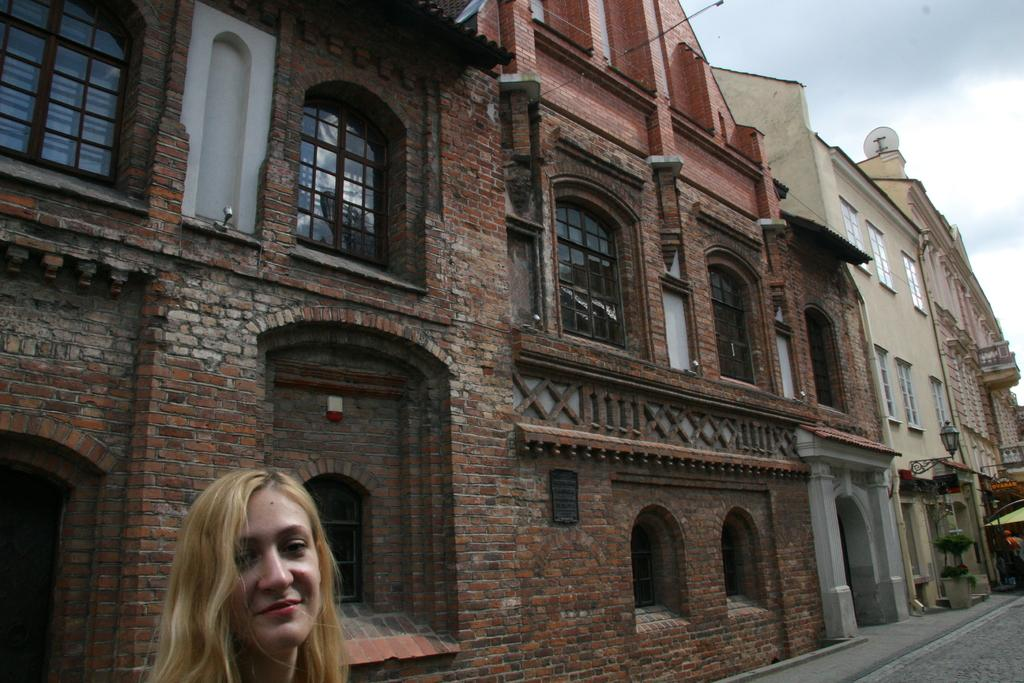Who is present in the image? There is a woman in the image. What is the woman's position in the image? The woman is standing on a path. What can be seen in the background of the image? There are buildings with windows in the background of the image. How would you describe the weather in the image? The sky is cloudy in the image. What type of stew is being cooked in the background of the image? There is no stew or cooking activity present in the image. 